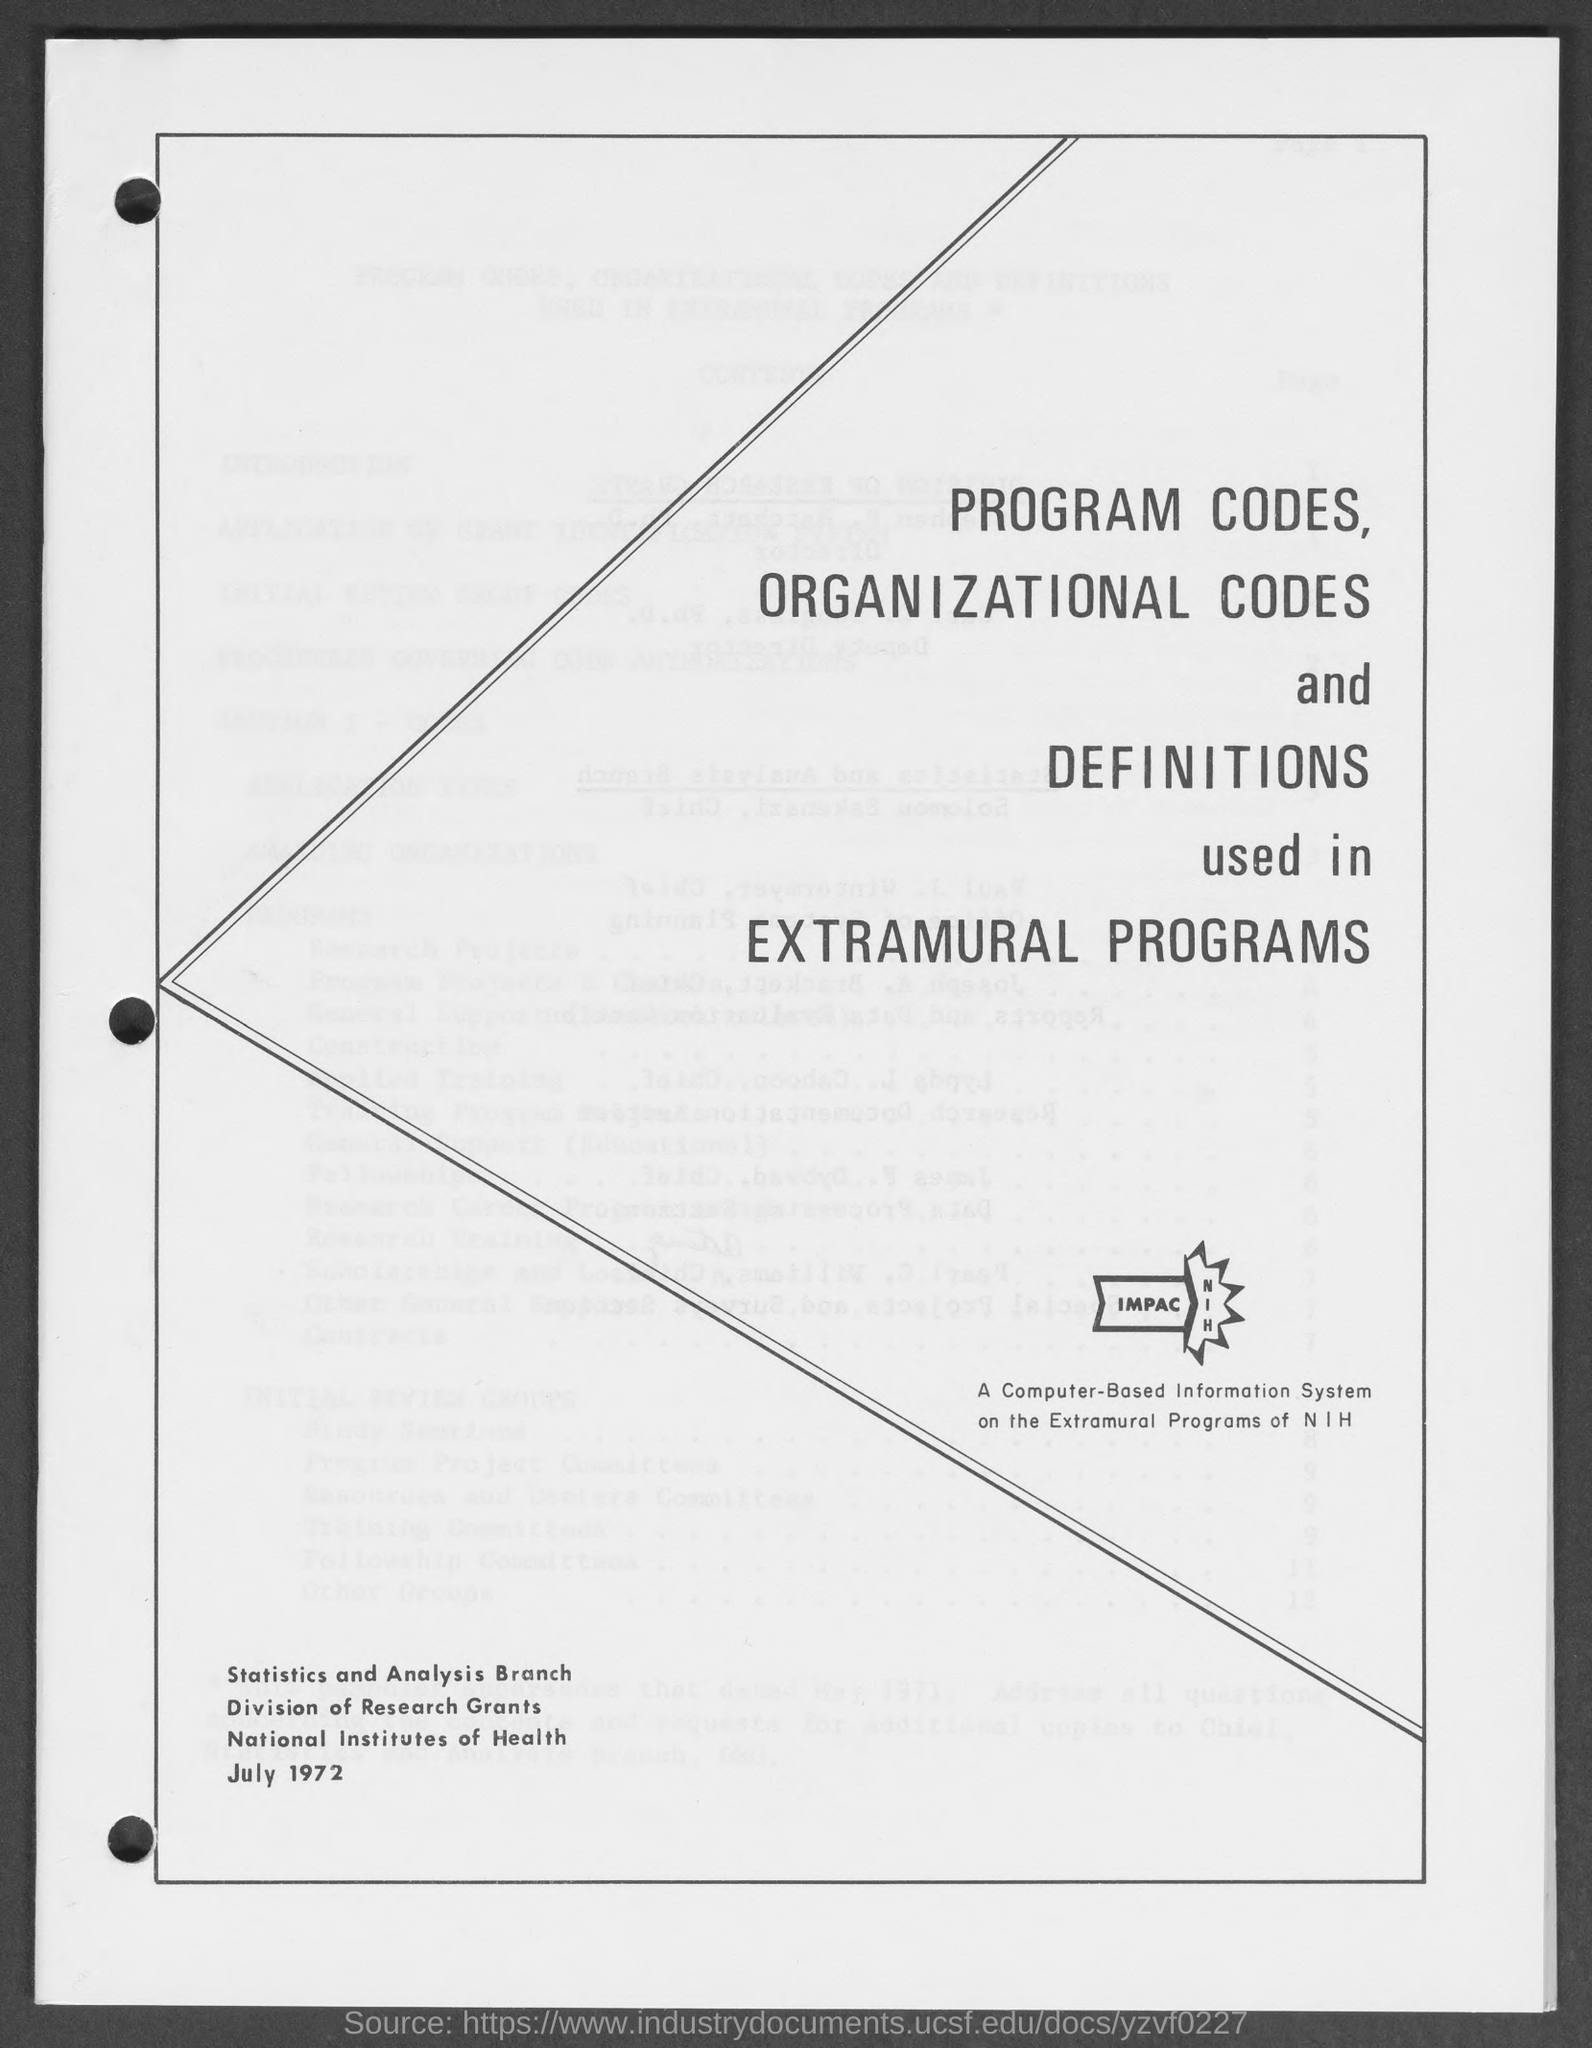Identify some key points in this picture. The month and year at the bottom of the page are July 1972. 